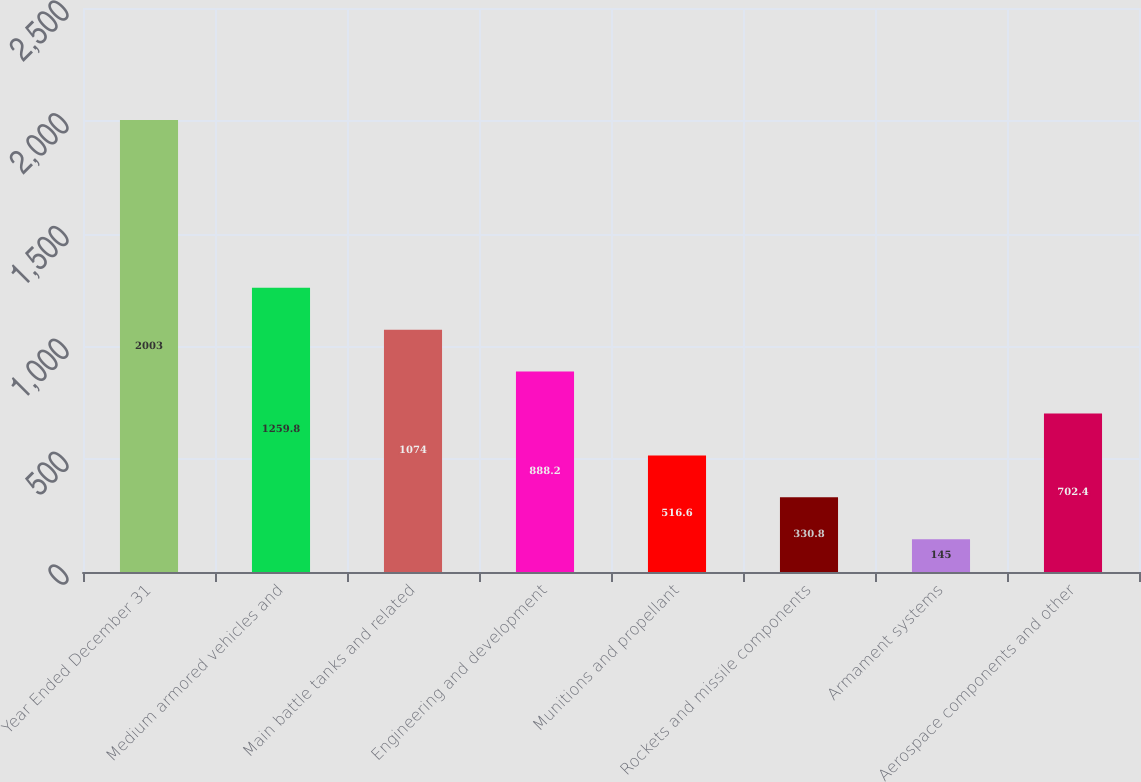Convert chart. <chart><loc_0><loc_0><loc_500><loc_500><bar_chart><fcel>Year Ended December 31<fcel>Medium armored vehicles and<fcel>Main battle tanks and related<fcel>Engineering and development<fcel>Munitions and propellant<fcel>Rockets and missile components<fcel>Armament systems<fcel>Aerospace components and other<nl><fcel>2003<fcel>1259.8<fcel>1074<fcel>888.2<fcel>516.6<fcel>330.8<fcel>145<fcel>702.4<nl></chart> 